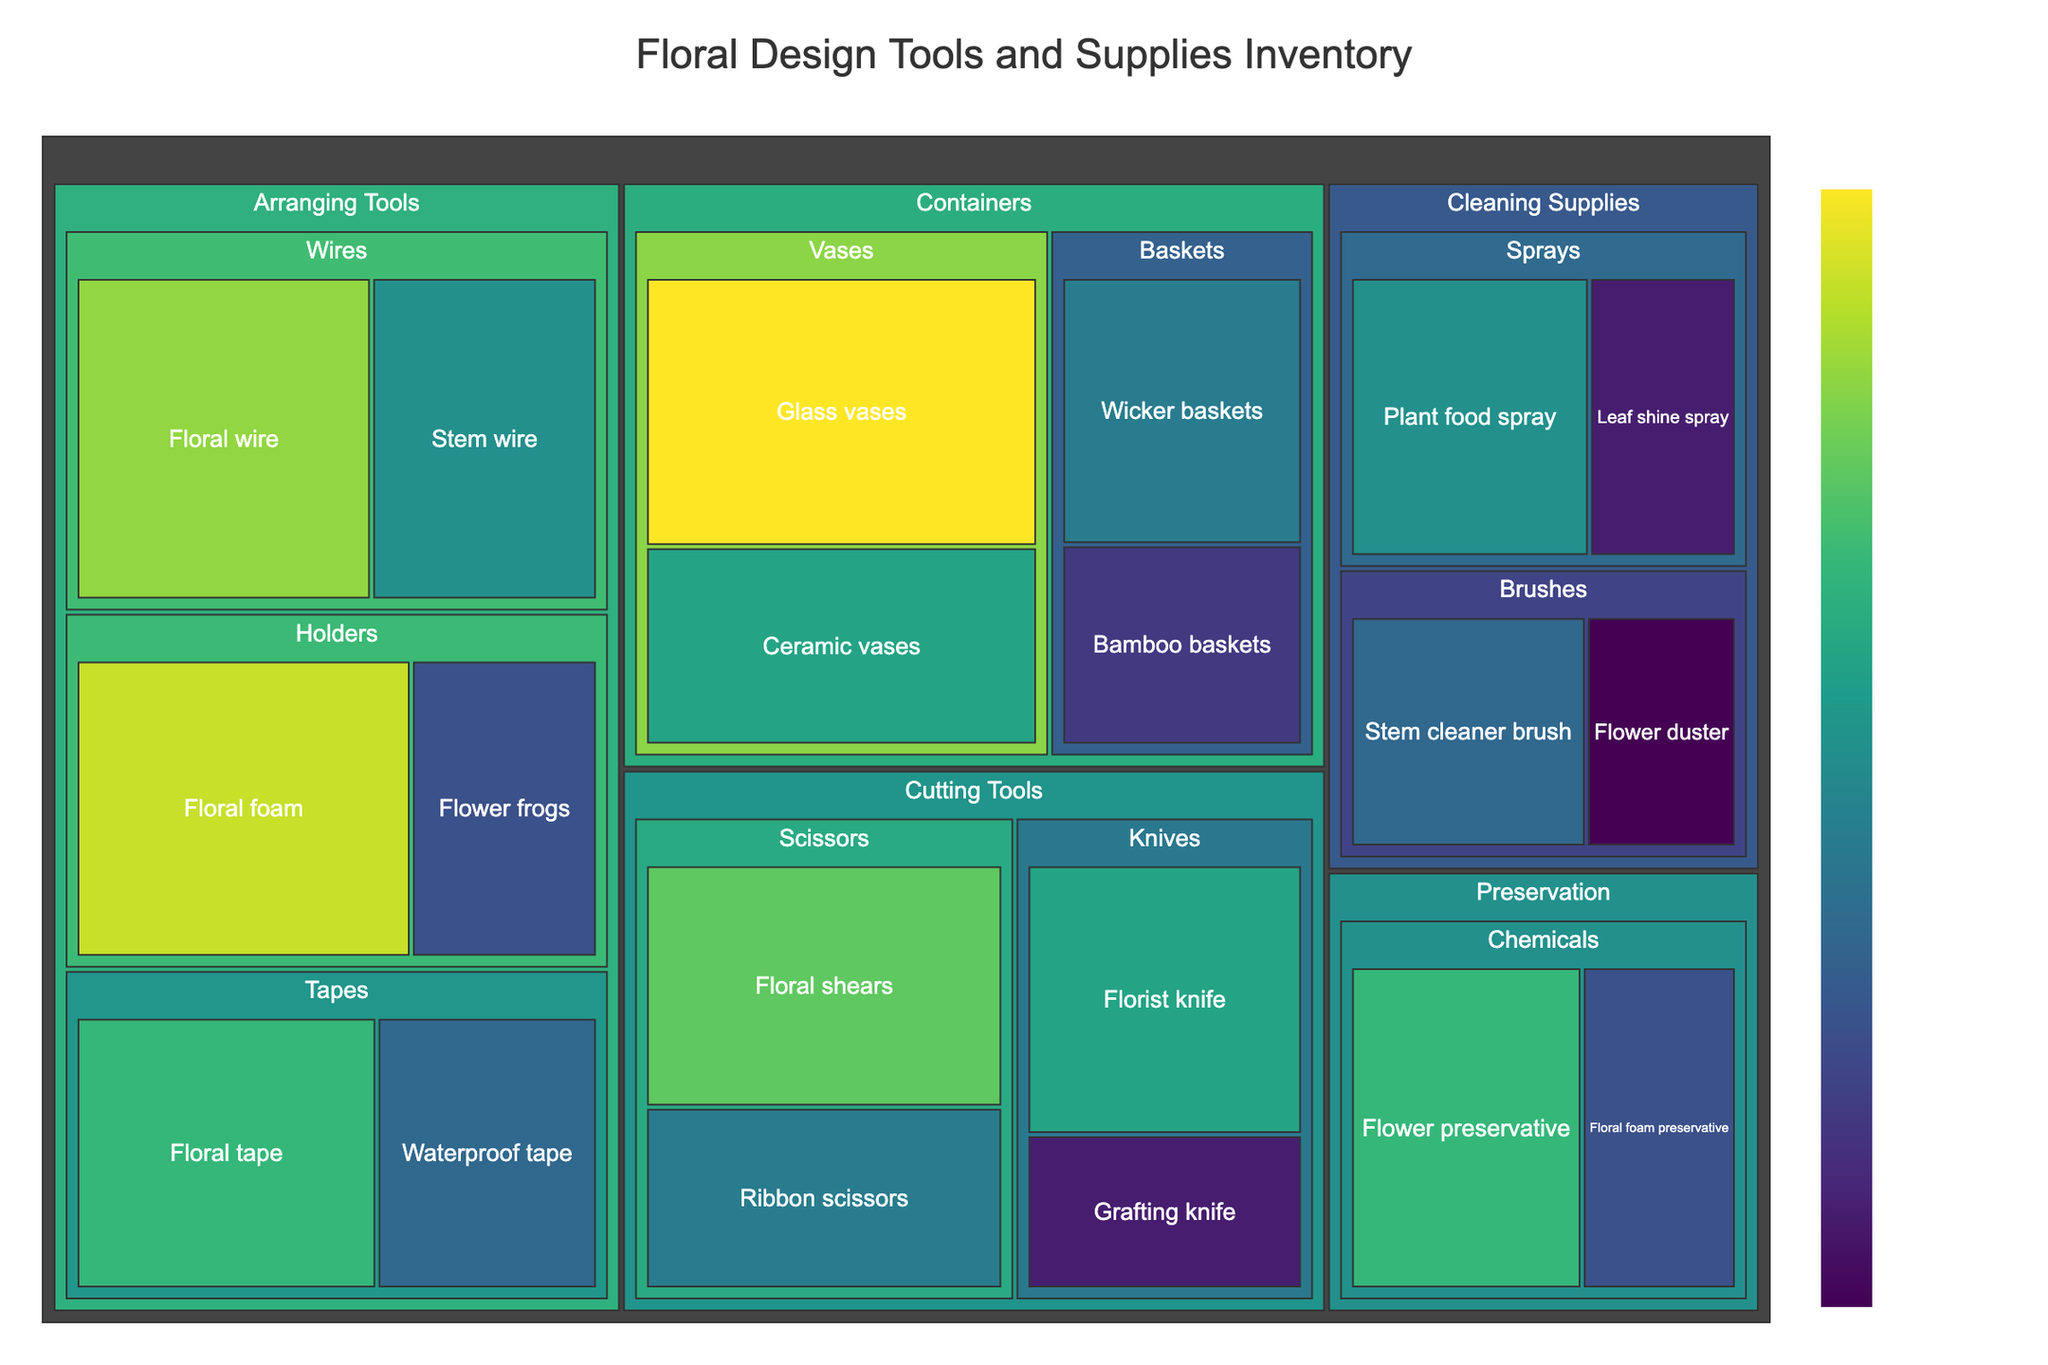What is the title of the Treemap? The title is displayed at the top of the Treemap.
Answer: Floral Design Tools and Supplies Inventory Which item has the highest frequency of use? By examining the Treemap, the item with the largest section/color intensity represents the highest frequency.
Answer: Glass vases Which subcategory in the “Cutting Tools” has higher total frequency, Scissors or Knives? Add the frequencies of items in each subcategory to compare. Scissors: Floral shears (80) + Ribbon scissors (60) = 140. Knives: Florist knife (70) + Grafting knife (40) = 110. Thus, Scissors have the higher total frequency.
Answer: Scissors How many unique categories are represented in the Treemap? The categories are typically the top-level divisions in a Treemap. Count the distinct sections.
Answer: 4 What is the combined frequency of “Preservation” tools? Summing the values of items under Preservation: Flower preservative (75) + Floral foam preservative (50) = 125.
Answer: 125 Which subcategory in “Containers” has the lowest frequency of use? Comparing the values of the items under each subcategory: Vases: Glass vases (95), Ceramic vases (70); Baskets: Wicker baskets (60), Bamboo baskets (45). The lowest value among these is Bamboo baskets.
Answer: Bamboo baskets Between “Floral tape” and “Waterproof tape,” which is used more frequently? Directly comparing their values in the Treemap: Floral tape (75) is higher than Waterproof tape (55).
Answer: Floral tape What is the frequency difference between “Plant food spray” and “Leaf shine spray”? Subtract the value of Leaf shine spray (40) from Plant food spray (65).
Answer: 25 What's the average frequency of items in the “Cleaning Supplies” category? Sum the values of Cleaning Supplies items: Plant food spray (65) + Leaf shine spray (40) + Stem cleaner brush (55) + Flower duster (35) = 195. Divide by number of items, 195/4.
Answer: 48.75 What percentage of the “Arranging Tools” category's total frequency is the "Floral foam"? First, calculate the total frequency of the "Arranging Tools" (Floral foam (90) + Flower frogs (50) + Floral wire (85) + Stem wire (65) + Floral tape (75) + Waterproof tape (55) = 420). Then calculate the percentage: (90 / 420) * 100%.
Answer: 21.4% 